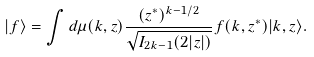Convert formula to latex. <formula><loc_0><loc_0><loc_500><loc_500>| f \rangle = \int d \mu ( k , z ) \frac { ( z ^ { \ast } ) ^ { k - 1 / 2 } } { \sqrt { I _ { 2 k - 1 } ( 2 | z | ) } } f ( k , z ^ { \ast } ) | k , z \rangle .</formula> 